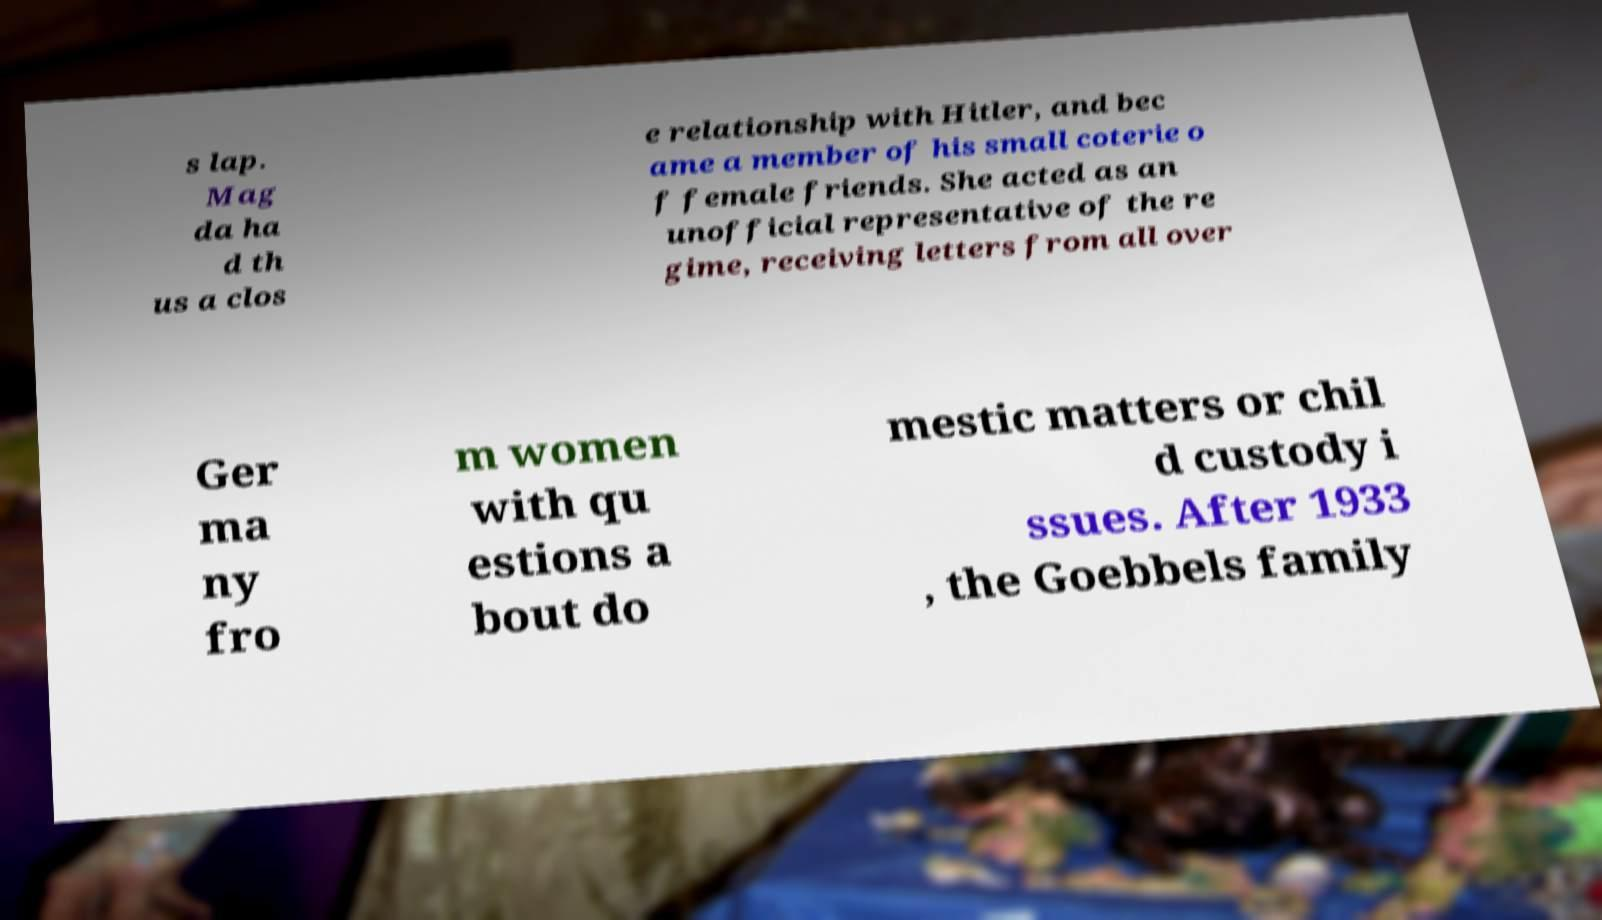Could you extract and type out the text from this image? s lap. Mag da ha d th us a clos e relationship with Hitler, and bec ame a member of his small coterie o f female friends. She acted as an unofficial representative of the re gime, receiving letters from all over Ger ma ny fro m women with qu estions a bout do mestic matters or chil d custody i ssues. After 1933 , the Goebbels family 